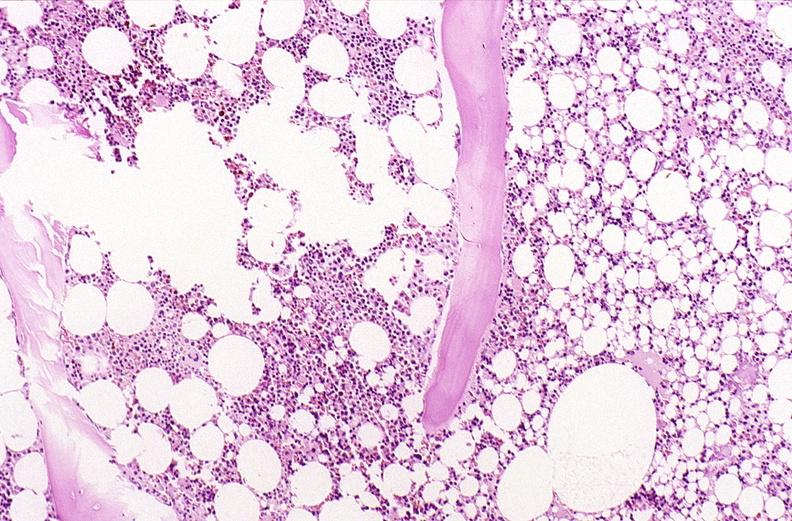s musculoskeletal present?
Answer the question using a single word or phrase. Yes 